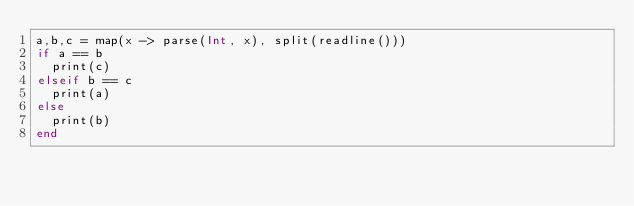Convert code to text. <code><loc_0><loc_0><loc_500><loc_500><_Julia_>a,b,c = map(x -> parse(Int, x), split(readline()))
if a == b
  print(c)
elseif b == c
  print(a)
else
  print(b)
end</code> 